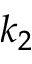<formula> <loc_0><loc_0><loc_500><loc_500>k _ { 2 }</formula> 